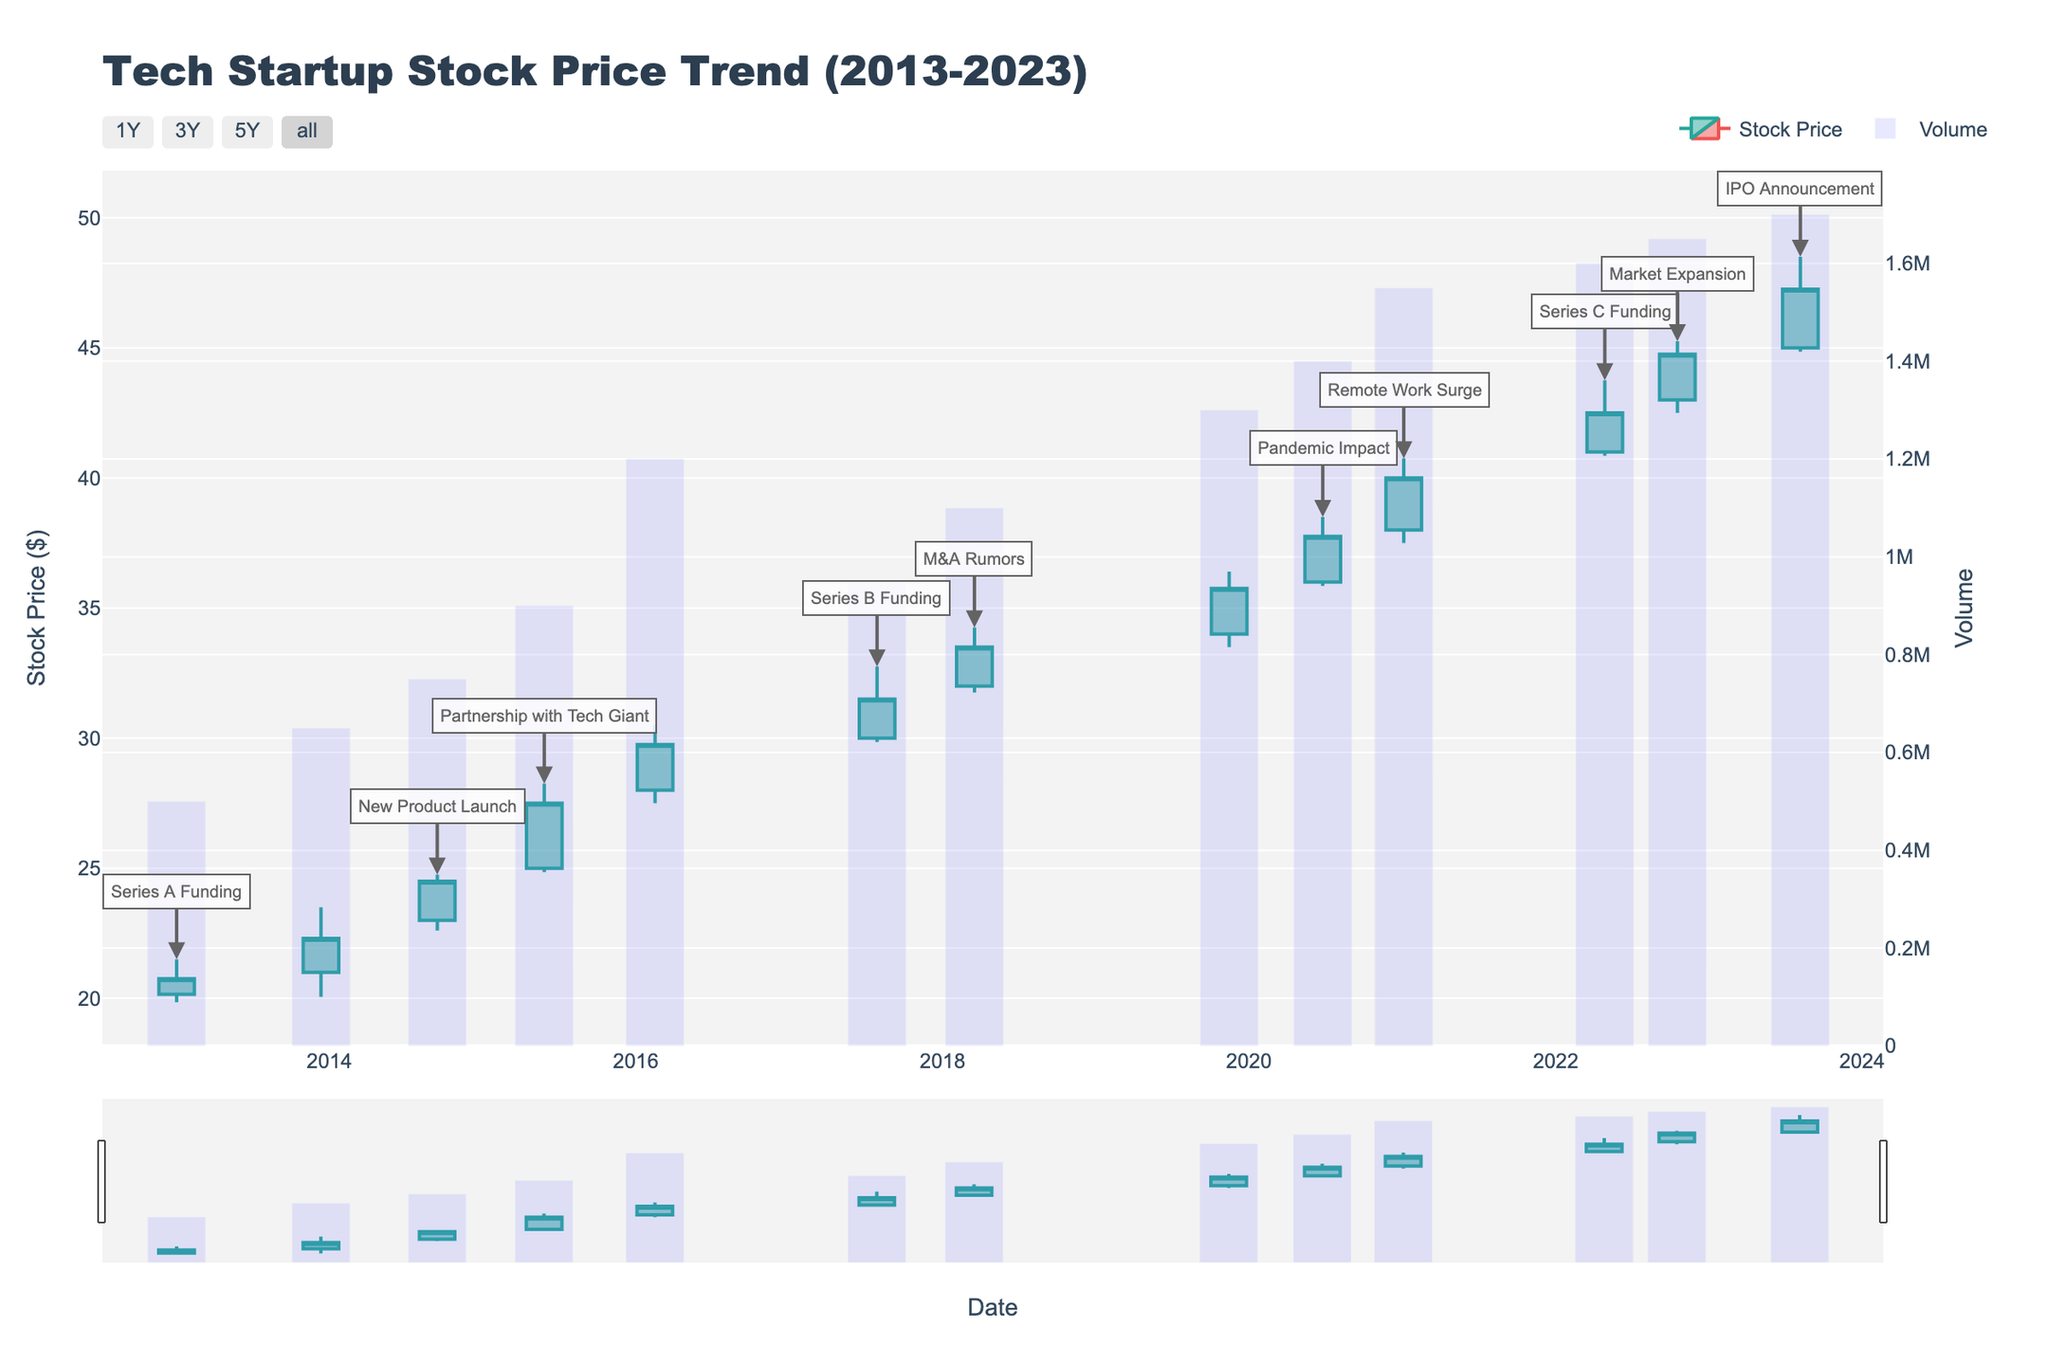What is the title of the figure? The title of the figure is prominently displayed at the top and is labeled "Tech Startup Stock Price Trend (2013-2023)".
Answer: Tech Startup Stock Price Trend (2013-2023) Which event occurred on 2023-08-07? By examining the data points and the annotation text on the candlestick for 2023-08-07, it is noted that the event described is "IPO Announcement".
Answer: IPO Announcement How did the stock price react to the New Product Launch on 2014-09-15? Referring to the candlestick on 2014-09-15, the stock's opening price was $23.00 and the closing price was $24.50, indicating a positive reaction as the stock price increased.
Answer: The stock price increased What was the highest stock price reached on the day of the Series B Funding on 2017-07-29? The candlestick for 2017-07-29 shows the high value, which represents the highest stock price reached that day. It is noted as $32.75.
Answer: $32.75 Compare the trading volume on the day of the Series A Funding with the day of the Series C Funding. The volumes on the respective days are shown on the volume bar chart. The trading volume on Series A Funding day (2013-01-02) was 500,000, while on Series C Funding day (2022-04-28), it was 1,600,000.
Answer: 1,600,000 is greater Identify the date range where the highest stock price (high) has been reached based on the candlesticks. By observing the candlestick highs, the highest value appears to be on 2023-08-07 with a high of $48.50, within the date range of January 2013 to August 2023.
Answer: 2023-08-07 What trend can be observed in stock prices following the partnership with a tech giant announced on 2015-05-28? Observing the candlesticks following 2015-05-28, the stock prices exhibit an upward trend, depicted by the closing prices on subsequent dates being higher than before.
Answer: Upward trend How did the stock price react to the Pandemic Impact event on 2020-06-25? On the candlestick for 2020-06-25, the closing price was $37.75, while the opening price that day was $36.00, indicating an increase in stock price.
Answer: Stock price increased What was the closing stock price on the day Remote Work Surge was annotated? The candlestick for 2021-01-04 shows the closing price for that day, which is indicated as $40.00.
Answer: $40.00 